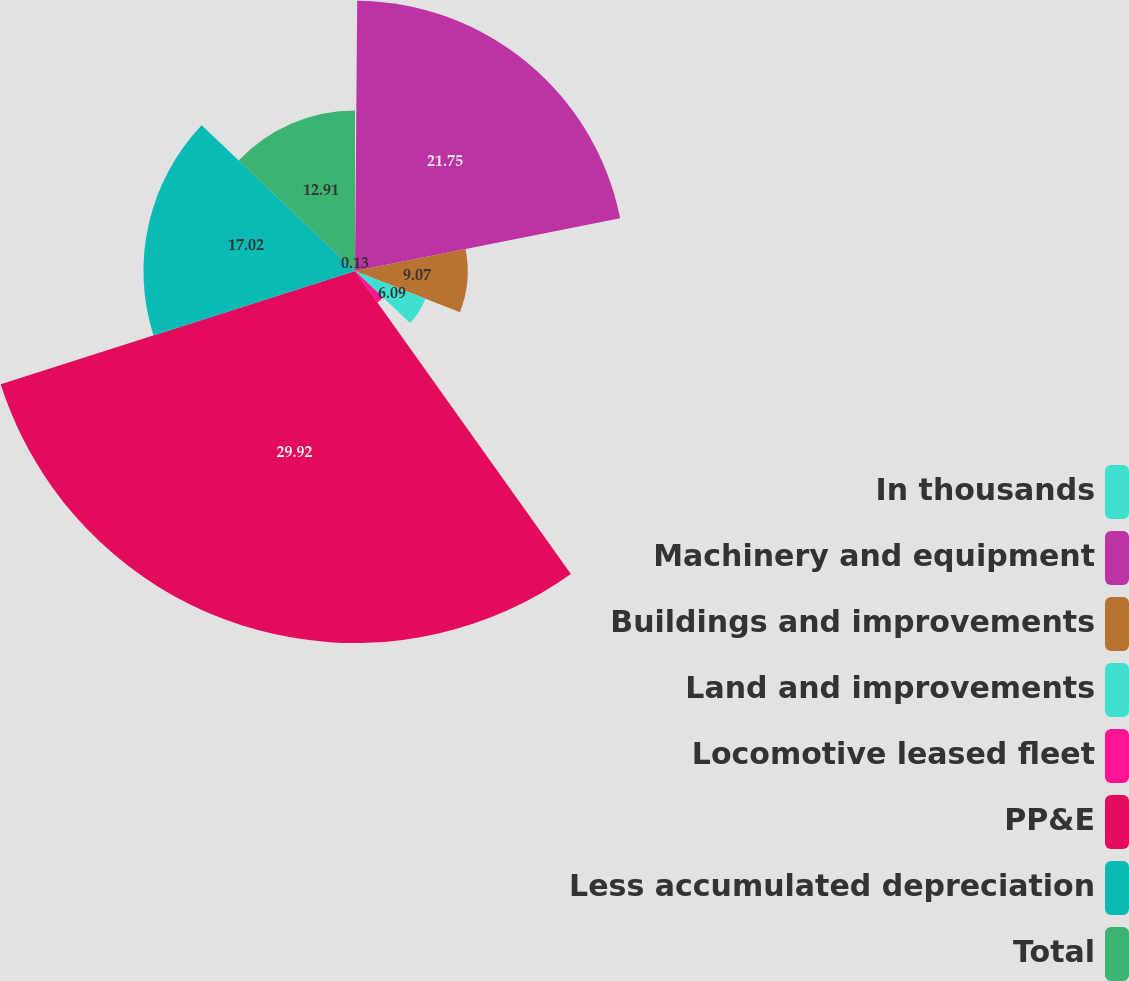Convert chart. <chart><loc_0><loc_0><loc_500><loc_500><pie_chart><fcel>In thousands<fcel>Machinery and equipment<fcel>Buildings and improvements<fcel>Land and improvements<fcel>Locomotive leased fleet<fcel>PP&E<fcel>Less accumulated depreciation<fcel>Total<nl><fcel>0.13%<fcel>21.75%<fcel>9.07%<fcel>6.09%<fcel>3.11%<fcel>29.93%<fcel>17.02%<fcel>12.91%<nl></chart> 